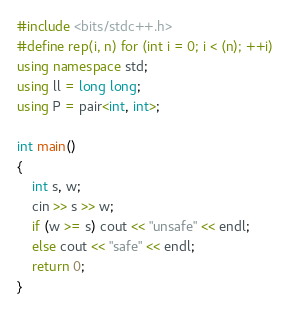<code> <loc_0><loc_0><loc_500><loc_500><_C++_>#include <bits/stdc++.h>
#define rep(i, n) for (int i = 0; i < (n); ++i)
using namespace std;
using ll = long long;
using P = pair<int, int>;

int main()
{
    int s, w;
    cin >> s >> w;
    if (w >= s) cout << "unsafe" << endl;
    else cout << "safe" << endl;
    return 0;
}</code> 